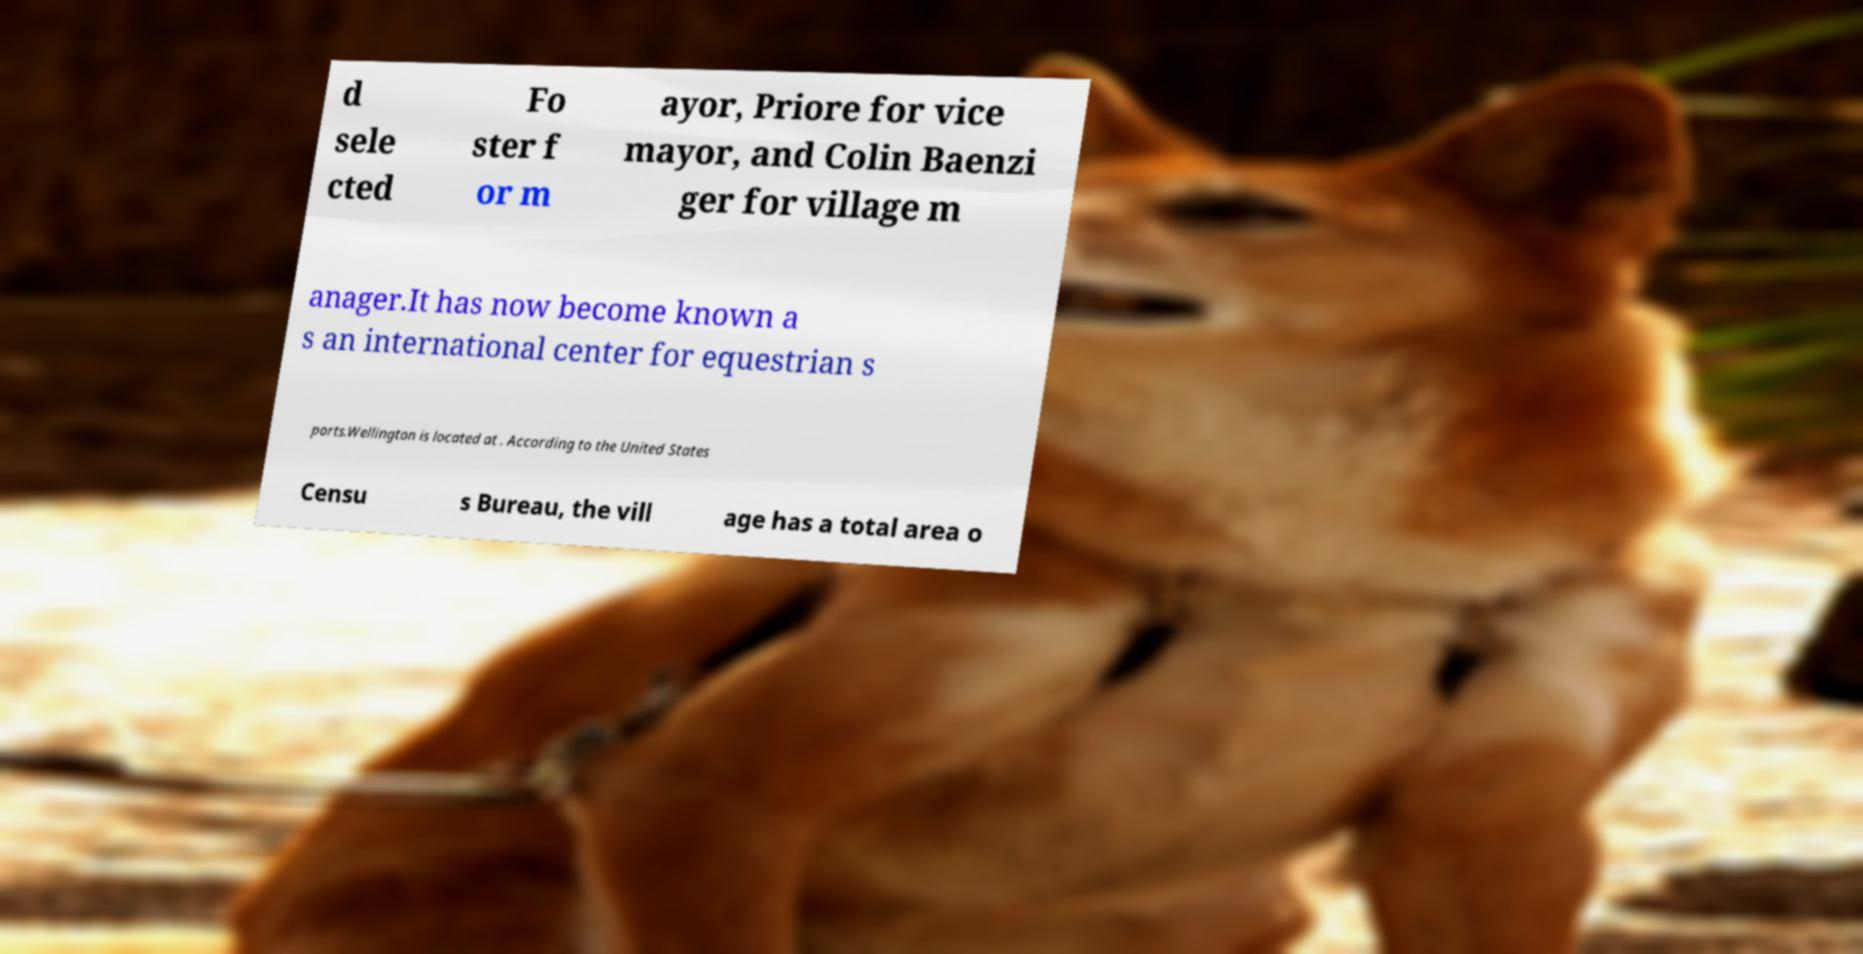Could you extract and type out the text from this image? d sele cted Fo ster f or m ayor, Priore for vice mayor, and Colin Baenzi ger for village m anager.It has now become known a s an international center for equestrian s ports.Wellington is located at . According to the United States Censu s Bureau, the vill age has a total area o 